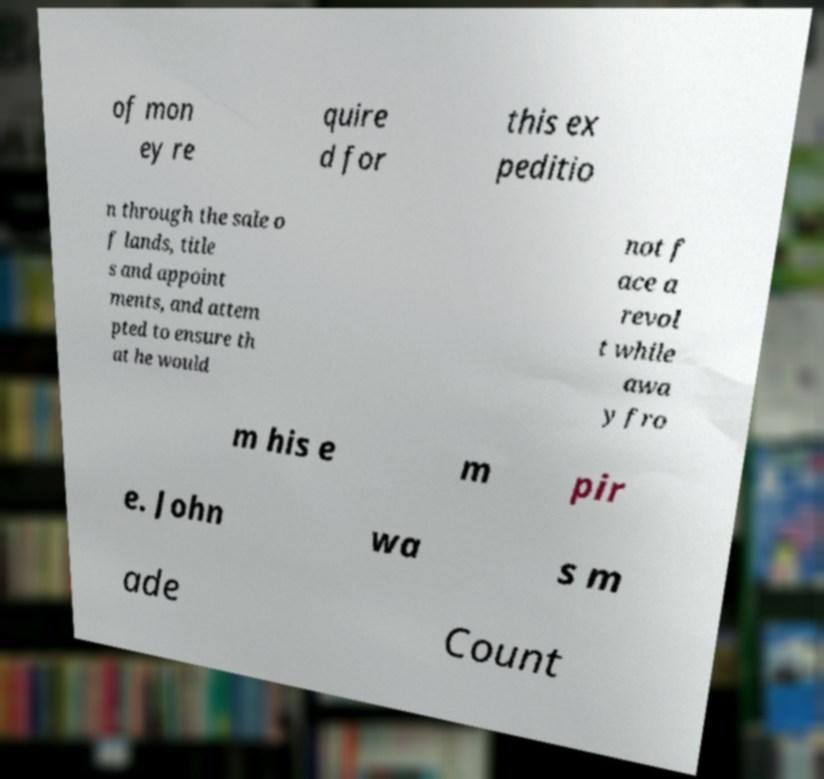Can you accurately transcribe the text from the provided image for me? of mon ey re quire d for this ex peditio n through the sale o f lands, title s and appoint ments, and attem pted to ensure th at he would not f ace a revol t while awa y fro m his e m pir e. John wa s m ade Count 